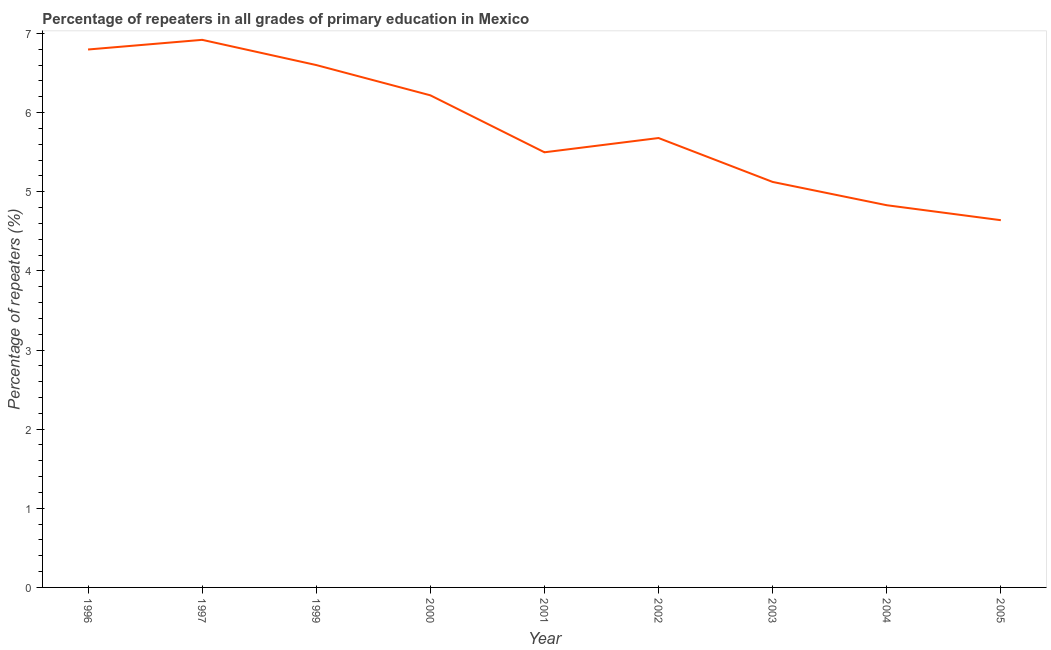What is the percentage of repeaters in primary education in 2005?
Offer a very short reply. 4.64. Across all years, what is the maximum percentage of repeaters in primary education?
Your answer should be very brief. 6.92. Across all years, what is the minimum percentage of repeaters in primary education?
Ensure brevity in your answer.  4.64. In which year was the percentage of repeaters in primary education maximum?
Offer a very short reply. 1997. In which year was the percentage of repeaters in primary education minimum?
Offer a terse response. 2005. What is the sum of the percentage of repeaters in primary education?
Ensure brevity in your answer.  52.31. What is the difference between the percentage of repeaters in primary education in 2003 and 2005?
Provide a short and direct response. 0.48. What is the average percentage of repeaters in primary education per year?
Ensure brevity in your answer.  5.81. What is the median percentage of repeaters in primary education?
Your response must be concise. 5.68. In how many years, is the percentage of repeaters in primary education greater than 0.2 %?
Your answer should be compact. 9. What is the ratio of the percentage of repeaters in primary education in 1996 to that in 2004?
Ensure brevity in your answer.  1.41. Is the percentage of repeaters in primary education in 1996 less than that in 2004?
Your response must be concise. No. Is the difference between the percentage of repeaters in primary education in 1997 and 2002 greater than the difference between any two years?
Provide a succinct answer. No. What is the difference between the highest and the second highest percentage of repeaters in primary education?
Offer a very short reply. 0.12. What is the difference between the highest and the lowest percentage of repeaters in primary education?
Your response must be concise. 2.28. In how many years, is the percentage of repeaters in primary education greater than the average percentage of repeaters in primary education taken over all years?
Offer a very short reply. 4. How many years are there in the graph?
Offer a very short reply. 9. Does the graph contain grids?
Provide a short and direct response. No. What is the title of the graph?
Offer a very short reply. Percentage of repeaters in all grades of primary education in Mexico. What is the label or title of the Y-axis?
Provide a succinct answer. Percentage of repeaters (%). What is the Percentage of repeaters (%) in 1996?
Keep it short and to the point. 6.8. What is the Percentage of repeaters (%) of 1997?
Make the answer very short. 6.92. What is the Percentage of repeaters (%) in 1999?
Your answer should be very brief. 6.6. What is the Percentage of repeaters (%) in 2000?
Give a very brief answer. 6.22. What is the Percentage of repeaters (%) in 2001?
Offer a terse response. 5.5. What is the Percentage of repeaters (%) of 2002?
Provide a short and direct response. 5.68. What is the Percentage of repeaters (%) in 2003?
Your answer should be compact. 5.12. What is the Percentage of repeaters (%) of 2004?
Offer a terse response. 4.83. What is the Percentage of repeaters (%) of 2005?
Your response must be concise. 4.64. What is the difference between the Percentage of repeaters (%) in 1996 and 1997?
Offer a very short reply. -0.12. What is the difference between the Percentage of repeaters (%) in 1996 and 1999?
Your answer should be very brief. 0.2. What is the difference between the Percentage of repeaters (%) in 1996 and 2000?
Make the answer very short. 0.58. What is the difference between the Percentage of repeaters (%) in 1996 and 2001?
Your response must be concise. 1.3. What is the difference between the Percentage of repeaters (%) in 1996 and 2002?
Your answer should be compact. 1.12. What is the difference between the Percentage of repeaters (%) in 1996 and 2003?
Provide a succinct answer. 1.67. What is the difference between the Percentage of repeaters (%) in 1996 and 2004?
Provide a succinct answer. 1.97. What is the difference between the Percentage of repeaters (%) in 1996 and 2005?
Offer a terse response. 2.16. What is the difference between the Percentage of repeaters (%) in 1997 and 1999?
Your response must be concise. 0.32. What is the difference between the Percentage of repeaters (%) in 1997 and 2000?
Give a very brief answer. 0.7. What is the difference between the Percentage of repeaters (%) in 1997 and 2001?
Give a very brief answer. 1.42. What is the difference between the Percentage of repeaters (%) in 1997 and 2002?
Ensure brevity in your answer.  1.24. What is the difference between the Percentage of repeaters (%) in 1997 and 2003?
Your answer should be very brief. 1.8. What is the difference between the Percentage of repeaters (%) in 1997 and 2004?
Provide a short and direct response. 2.09. What is the difference between the Percentage of repeaters (%) in 1997 and 2005?
Offer a very short reply. 2.28. What is the difference between the Percentage of repeaters (%) in 1999 and 2000?
Ensure brevity in your answer.  0.38. What is the difference between the Percentage of repeaters (%) in 1999 and 2001?
Provide a short and direct response. 1.1. What is the difference between the Percentage of repeaters (%) in 1999 and 2002?
Your answer should be very brief. 0.92. What is the difference between the Percentage of repeaters (%) in 1999 and 2003?
Provide a succinct answer. 1.48. What is the difference between the Percentage of repeaters (%) in 1999 and 2004?
Ensure brevity in your answer.  1.77. What is the difference between the Percentage of repeaters (%) in 1999 and 2005?
Ensure brevity in your answer.  1.96. What is the difference between the Percentage of repeaters (%) in 2000 and 2001?
Keep it short and to the point. 0.72. What is the difference between the Percentage of repeaters (%) in 2000 and 2002?
Keep it short and to the point. 0.54. What is the difference between the Percentage of repeaters (%) in 2000 and 2003?
Your answer should be very brief. 1.09. What is the difference between the Percentage of repeaters (%) in 2000 and 2004?
Provide a succinct answer. 1.39. What is the difference between the Percentage of repeaters (%) in 2000 and 2005?
Your response must be concise. 1.58. What is the difference between the Percentage of repeaters (%) in 2001 and 2002?
Ensure brevity in your answer.  -0.18. What is the difference between the Percentage of repeaters (%) in 2001 and 2003?
Your answer should be very brief. 0.37. What is the difference between the Percentage of repeaters (%) in 2001 and 2004?
Ensure brevity in your answer.  0.67. What is the difference between the Percentage of repeaters (%) in 2001 and 2005?
Offer a terse response. 0.86. What is the difference between the Percentage of repeaters (%) in 2002 and 2003?
Make the answer very short. 0.55. What is the difference between the Percentage of repeaters (%) in 2002 and 2004?
Keep it short and to the point. 0.85. What is the difference between the Percentage of repeaters (%) in 2002 and 2005?
Your answer should be compact. 1.04. What is the difference between the Percentage of repeaters (%) in 2003 and 2004?
Make the answer very short. 0.29. What is the difference between the Percentage of repeaters (%) in 2003 and 2005?
Make the answer very short. 0.48. What is the difference between the Percentage of repeaters (%) in 2004 and 2005?
Give a very brief answer. 0.19. What is the ratio of the Percentage of repeaters (%) in 1996 to that in 1997?
Ensure brevity in your answer.  0.98. What is the ratio of the Percentage of repeaters (%) in 1996 to that in 1999?
Ensure brevity in your answer.  1.03. What is the ratio of the Percentage of repeaters (%) in 1996 to that in 2000?
Offer a terse response. 1.09. What is the ratio of the Percentage of repeaters (%) in 1996 to that in 2001?
Your response must be concise. 1.24. What is the ratio of the Percentage of repeaters (%) in 1996 to that in 2002?
Offer a very short reply. 1.2. What is the ratio of the Percentage of repeaters (%) in 1996 to that in 2003?
Make the answer very short. 1.33. What is the ratio of the Percentage of repeaters (%) in 1996 to that in 2004?
Your answer should be compact. 1.41. What is the ratio of the Percentage of repeaters (%) in 1996 to that in 2005?
Your response must be concise. 1.47. What is the ratio of the Percentage of repeaters (%) in 1997 to that in 1999?
Ensure brevity in your answer.  1.05. What is the ratio of the Percentage of repeaters (%) in 1997 to that in 2000?
Provide a short and direct response. 1.11. What is the ratio of the Percentage of repeaters (%) in 1997 to that in 2001?
Make the answer very short. 1.26. What is the ratio of the Percentage of repeaters (%) in 1997 to that in 2002?
Offer a very short reply. 1.22. What is the ratio of the Percentage of repeaters (%) in 1997 to that in 2003?
Your response must be concise. 1.35. What is the ratio of the Percentage of repeaters (%) in 1997 to that in 2004?
Keep it short and to the point. 1.43. What is the ratio of the Percentage of repeaters (%) in 1997 to that in 2005?
Provide a short and direct response. 1.49. What is the ratio of the Percentage of repeaters (%) in 1999 to that in 2000?
Your answer should be compact. 1.06. What is the ratio of the Percentage of repeaters (%) in 1999 to that in 2002?
Make the answer very short. 1.16. What is the ratio of the Percentage of repeaters (%) in 1999 to that in 2003?
Your answer should be compact. 1.29. What is the ratio of the Percentage of repeaters (%) in 1999 to that in 2004?
Offer a very short reply. 1.37. What is the ratio of the Percentage of repeaters (%) in 1999 to that in 2005?
Your response must be concise. 1.42. What is the ratio of the Percentage of repeaters (%) in 2000 to that in 2001?
Provide a short and direct response. 1.13. What is the ratio of the Percentage of repeaters (%) in 2000 to that in 2002?
Your response must be concise. 1.09. What is the ratio of the Percentage of repeaters (%) in 2000 to that in 2003?
Keep it short and to the point. 1.21. What is the ratio of the Percentage of repeaters (%) in 2000 to that in 2004?
Keep it short and to the point. 1.29. What is the ratio of the Percentage of repeaters (%) in 2000 to that in 2005?
Offer a terse response. 1.34. What is the ratio of the Percentage of repeaters (%) in 2001 to that in 2003?
Offer a very short reply. 1.07. What is the ratio of the Percentage of repeaters (%) in 2001 to that in 2004?
Offer a terse response. 1.14. What is the ratio of the Percentage of repeaters (%) in 2001 to that in 2005?
Give a very brief answer. 1.19. What is the ratio of the Percentage of repeaters (%) in 2002 to that in 2003?
Ensure brevity in your answer.  1.11. What is the ratio of the Percentage of repeaters (%) in 2002 to that in 2004?
Provide a succinct answer. 1.18. What is the ratio of the Percentage of repeaters (%) in 2002 to that in 2005?
Make the answer very short. 1.22. What is the ratio of the Percentage of repeaters (%) in 2003 to that in 2004?
Keep it short and to the point. 1.06. What is the ratio of the Percentage of repeaters (%) in 2003 to that in 2005?
Give a very brief answer. 1.1. What is the ratio of the Percentage of repeaters (%) in 2004 to that in 2005?
Keep it short and to the point. 1.04. 